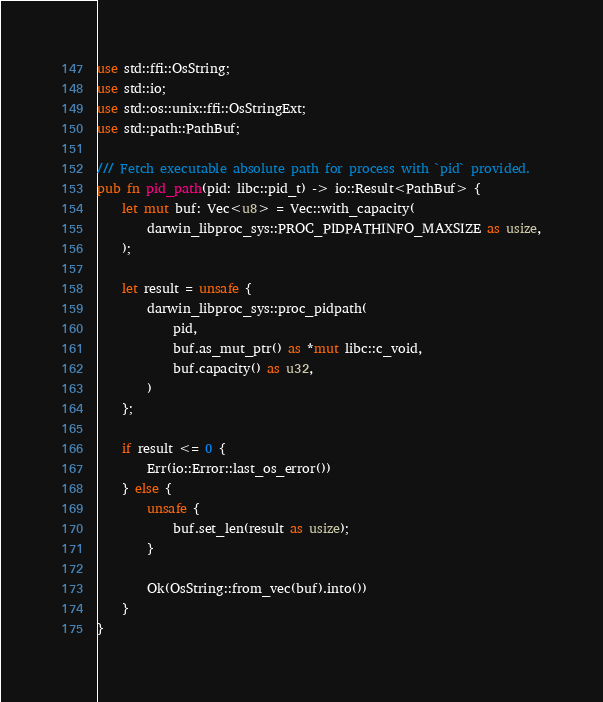<code> <loc_0><loc_0><loc_500><loc_500><_Rust_>use std::ffi::OsString;
use std::io;
use std::os::unix::ffi::OsStringExt;
use std::path::PathBuf;

/// Fetch executable absolute path for process with `pid` provided.
pub fn pid_path(pid: libc::pid_t) -> io::Result<PathBuf> {
    let mut buf: Vec<u8> = Vec::with_capacity(
        darwin_libproc_sys::PROC_PIDPATHINFO_MAXSIZE as usize,
    );

    let result = unsafe {
        darwin_libproc_sys::proc_pidpath(
            pid,
            buf.as_mut_ptr() as *mut libc::c_void,
            buf.capacity() as u32,
        )
    };

    if result <= 0 {
        Err(io::Error::last_os_error())
    } else {
        unsafe {
            buf.set_len(result as usize);
        }

        Ok(OsString::from_vec(buf).into())
    }
}
</code> 